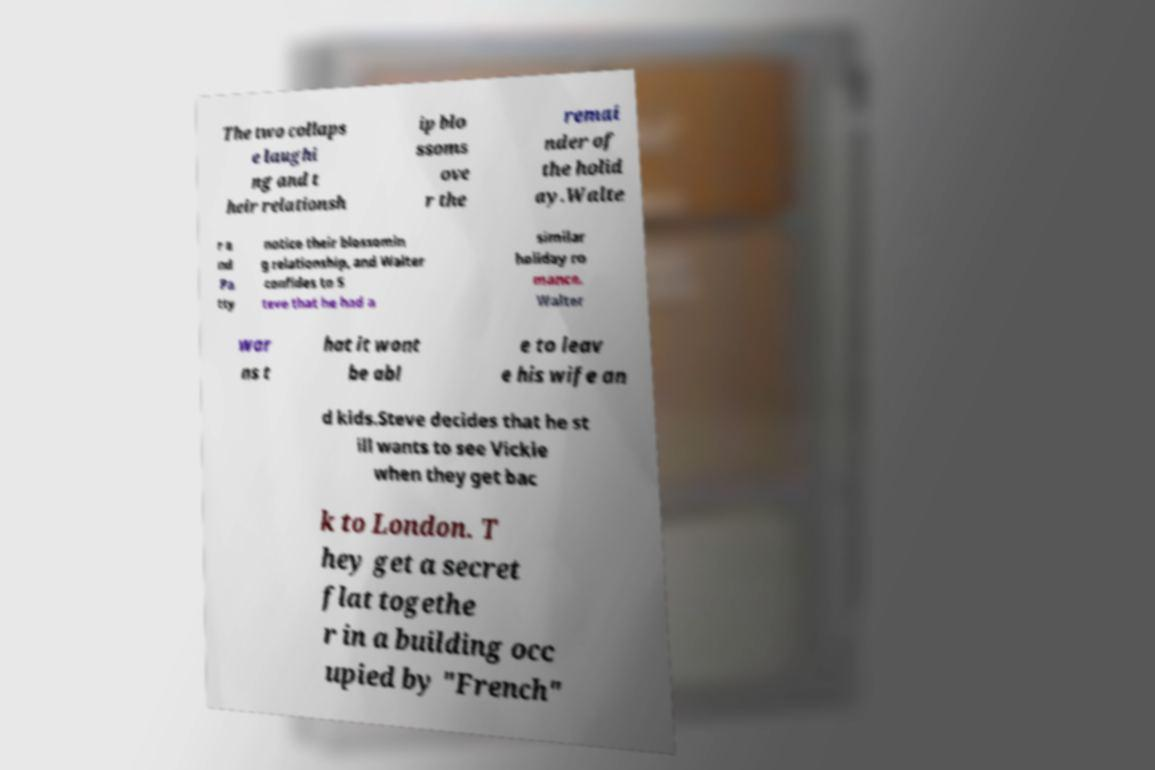I need the written content from this picture converted into text. Can you do that? The two collaps e laughi ng and t heir relationsh ip blo ssoms ove r the remai nder of the holid ay.Walte r a nd Pa tty notice their blossomin g relationship, and Walter confides to S teve that he had a similar holiday ro mance. Walter war ns t hat it wont be abl e to leav e his wife an d kids.Steve decides that he st ill wants to see Vickie when they get bac k to London. T hey get a secret flat togethe r in a building occ upied by "French" 